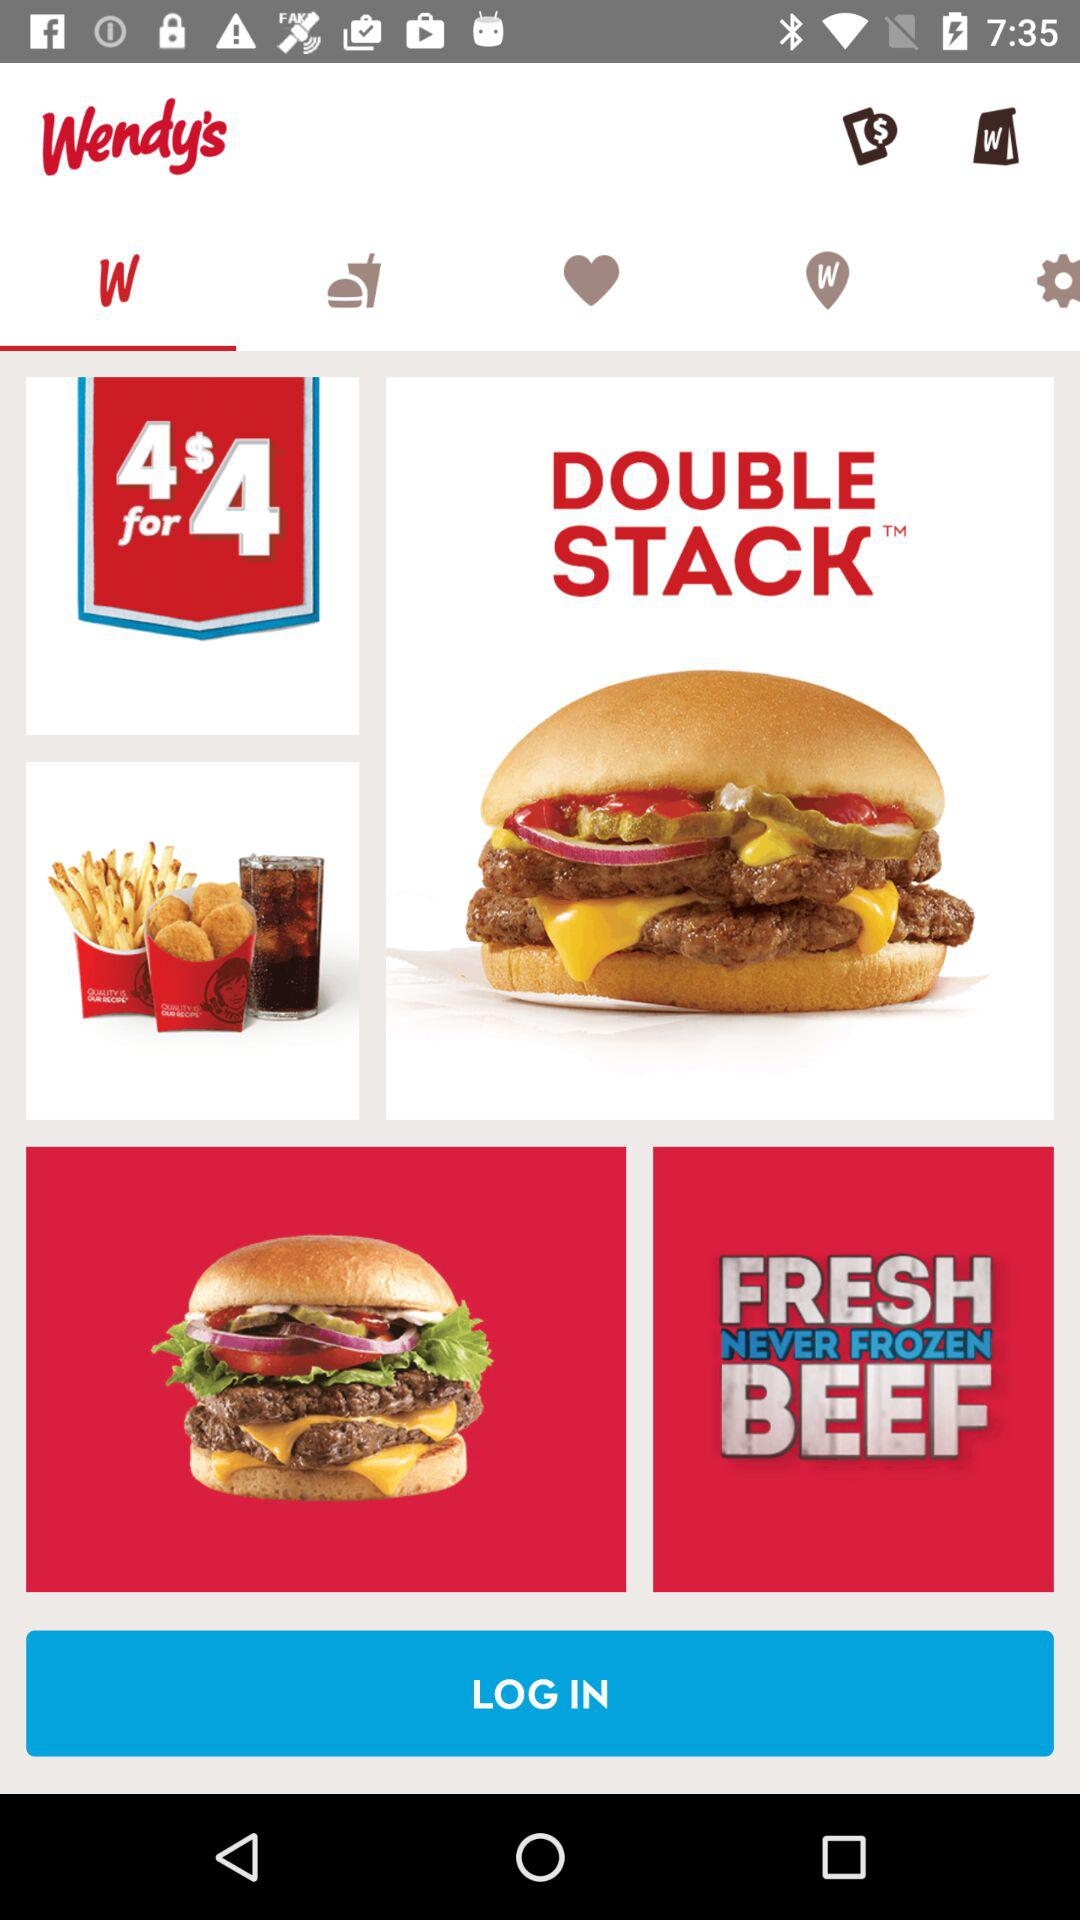What is the application name? The application name is "Wendy's". 